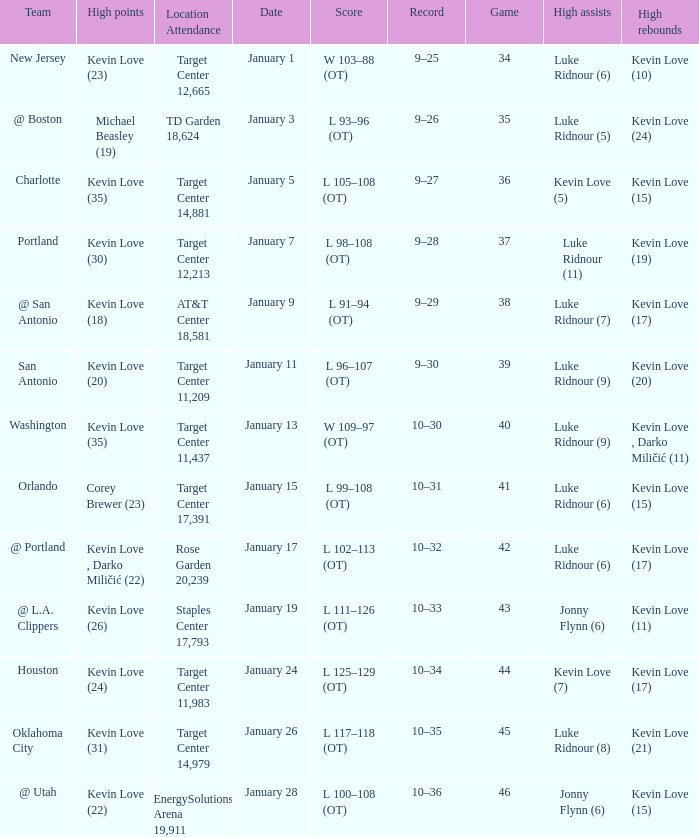What is the highest game with team @ l.a. clippers? 43.0. Would you mind parsing the complete table? {'header': ['Team', 'High points', 'Location Attendance', 'Date', 'Score', 'Record', 'Game', 'High assists', 'High rebounds'], 'rows': [['New Jersey', 'Kevin Love (23)', 'Target Center 12,665', 'January 1', 'W 103–88 (OT)', '9–25', '34', 'Luke Ridnour (6)', 'Kevin Love (10)'], ['@ Boston', 'Michael Beasley (19)', 'TD Garden 18,624', 'January 3', 'L 93–96 (OT)', '9–26', '35', 'Luke Ridnour (5)', 'Kevin Love (24)'], ['Charlotte', 'Kevin Love (35)', 'Target Center 14,881', 'January 5', 'L 105–108 (OT)', '9–27', '36', 'Kevin Love (5)', 'Kevin Love (15)'], ['Portland', 'Kevin Love (30)', 'Target Center 12,213', 'January 7', 'L 98–108 (OT)', '9–28', '37', 'Luke Ridnour (11)', 'Kevin Love (19)'], ['@ San Antonio', 'Kevin Love (18)', 'AT&T Center 18,581', 'January 9', 'L 91–94 (OT)', '9–29', '38', 'Luke Ridnour (7)', 'Kevin Love (17)'], ['San Antonio', 'Kevin Love (20)', 'Target Center 11,209', 'January 11', 'L 96–107 (OT)', '9–30', '39', 'Luke Ridnour (9)', 'Kevin Love (20)'], ['Washington', 'Kevin Love (35)', 'Target Center 11,437', 'January 13', 'W 109–97 (OT)', '10–30', '40', 'Luke Ridnour (9)', 'Kevin Love , Darko Miličić (11)'], ['Orlando', 'Corey Brewer (23)', 'Target Center 17,391', 'January 15', 'L 99–108 (OT)', '10–31', '41', 'Luke Ridnour (6)', 'Kevin Love (15)'], ['@ Portland', 'Kevin Love , Darko Miličić (22)', 'Rose Garden 20,239', 'January 17', 'L 102–113 (OT)', '10–32', '42', 'Luke Ridnour (6)', 'Kevin Love (17)'], ['@ L.A. Clippers', 'Kevin Love (26)', 'Staples Center 17,793', 'January 19', 'L 111–126 (OT)', '10–33', '43', 'Jonny Flynn (6)', 'Kevin Love (11)'], ['Houston', 'Kevin Love (24)', 'Target Center 11,983', 'January 24', 'L 125–129 (OT)', '10–34', '44', 'Kevin Love (7)', 'Kevin Love (17)'], ['Oklahoma City', 'Kevin Love (31)', 'Target Center 14,979', 'January 26', 'L 117–118 (OT)', '10–35', '45', 'Luke Ridnour (8)', 'Kevin Love (21)'], ['@ Utah', 'Kevin Love (22)', 'EnergySolutions Arena 19,911', 'January 28', 'L 100–108 (OT)', '10–36', '46', 'Jonny Flynn (6)', 'Kevin Love (15)']]} 